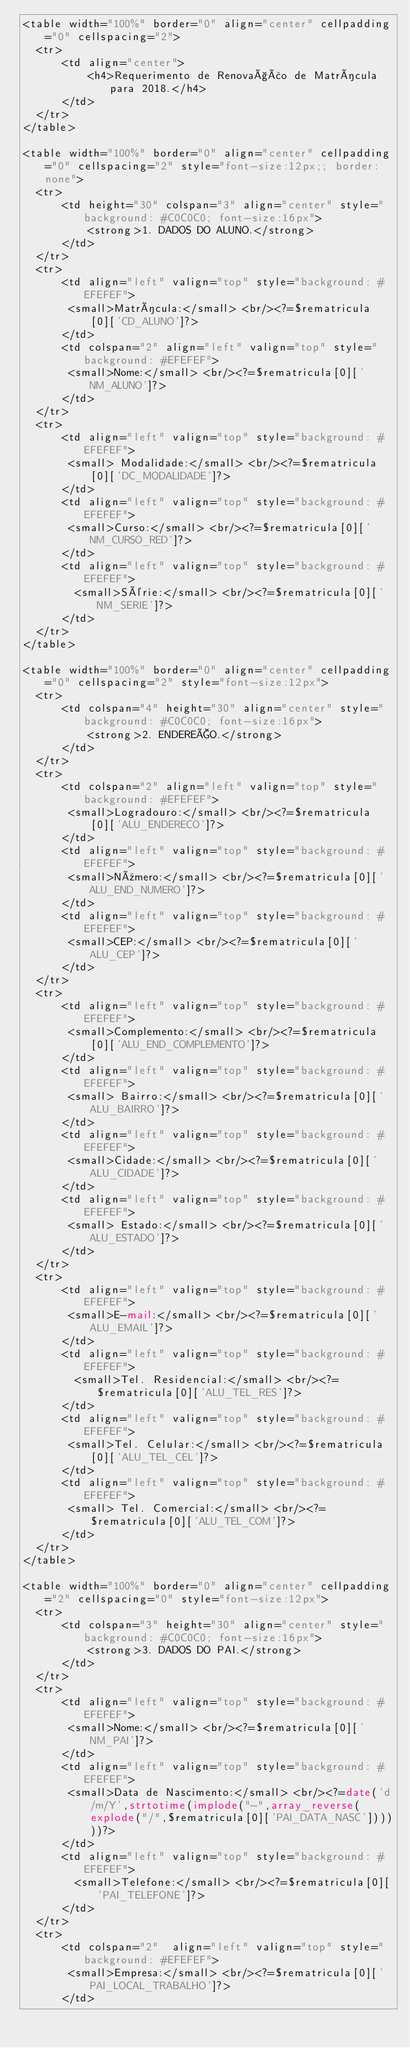<code> <loc_0><loc_0><loc_500><loc_500><_PHP_><table width="100%" border="0" align="center" cellpadding="0" cellspacing="2">
  <tr>
      <td align="center">
          <h4>Requerimento de Renovação de Matrícula para 2018.</h4>
      </td>
  </tr>
</table>

<table width="100%" border="0" align="center" cellpadding="0" cellspacing="2" style="font-size:12px;; border: none">
  <tr>
      <td height="30" colspan="3" align="center" style="background: #C0C0C0; font-size:16px">
          <strong>1. DADOS DO ALUNO.</strong>
      </td>
  </tr>
  <tr>
      <td align="left" valign="top" style="background: #EFEFEF">
       <small>Matrícula:</small> <br/><?=$rematricula[0]['CD_ALUNO']?>
      </td>  
      <td colspan="2" align="left" valign="top" style="background: #EFEFEF">
       <small>Nome:</small> <br/><?=$rematricula[0]['NM_ALUNO']?>
      </td>
  </tr>
  <tr>
      <td align="left" valign="top" style="background: #EFEFEF">
       <small> Modalidade:</small> <br/><?=$rematricula[0]['DC_MODALIDADE']?>  
      </td>
      <td align="left" valign="top" style="background: #EFEFEF">
       <small>Curso:</small> <br/><?=$rematricula[0]['NM_CURSO_RED']?>
      </td>
      <td align="left" valign="top" style="background: #EFEFEF">
        <small>Série:</small> <br/><?=$rematricula[0]['NM_SERIE']?>  
      </td>
  </tr>  
</table>

<table width="100%" border="0" align="center" cellpadding="0" cellspacing="2" style="font-size:12px">
  <tr>
      <td colspan="4" height="30" align="center" style="background: #C0C0C0; font-size:16px">
          <strong>2. ENDEREÇO.</strong>
      </td>
  </tr>
  <tr>
      <td colspan="2" align="left" valign="top" style="background: #EFEFEF">
       <small>Logradouro:</small> <br/><?=$rematricula[0]['ALU_ENDERECO']?>
      </td>
      <td align="left" valign="top" style="background: #EFEFEF">
       <small>Número:</small> <br/><?=$rematricula[0]['ALU_END_NUMERO']?>
      </td>
      <td align="left" valign="top" style="background: #EFEFEF">
       <small>CEP:</small> <br/><?=$rematricula[0]['ALU_CEP']?>
      </td>
  </tr>
  <tr>
      <td align="left" valign="top" style="background: #EFEFEF">
       <small>Complemento:</small> <br/><?=$rematricula[0]['ALU_END_COMPLEMENTO']?>
      </td>
      <td align="left" valign="top" style="background: #EFEFEF">
       <small> Bairro:</small> <br/><?=$rematricula[0]['ALU_BAIRRO']?>  
      </td>
      <td align="left" valign="top" style="background: #EFEFEF">
       <small>Cidade:</small> <br/><?=$rematricula[0]['ALU_CIDADE']?>
      </td>
      <td align="left" valign="top" style="background: #EFEFEF">
       <small> Estado:</small> <br/><?=$rematricula[0]['ALU_ESTADO']?>  
      </td>
  </tr>
  <tr>
      <td align="left" valign="top" style="background: #EFEFEF">
       <small>E-mail:</small> <br/><?=$rematricula[0]['ALU_EMAIL']?>
      </td>
      <td align="left" valign="top" style="background: #EFEFEF">
        <small>Tel. Residencial:</small> <br/><?=$rematricula[0]['ALU_TEL_RES']?>  
      </td>
      <td align="left" valign="top" style="background: #EFEFEF">
       <small>Tel. Celular:</small> <br/><?=$rematricula[0]['ALU_TEL_CEL']?>
      </td>
      <td align="left" valign="top" style="background: #EFEFEF">
       <small> Tel. Comercial:</small> <br/><?=$rematricula[0]['ALU_TEL_COM']?>  
      </td>
  </tr>
</table>

<table width="100%" border="0" align="center" cellpadding="2" cellspacing="0" style="font-size:12px">
  <tr>
      <td colspan="3" height="30" align="center" style="background: #C0C0C0; font-size:16px">
          <strong>3. DADOS DO PAI.</strong>
      </td>
  </tr>
  <tr>
      <td align="left" valign="top" style="background: #EFEFEF">
       <small>Nome:</small> <br/><?=$rematricula[0]['NM_PAI']?>
      </td>
      <td align="left" valign="top" style="background: #EFEFEF">
       <small>Data de Nascimento:</small> <br/><?=date('d/m/Y',strtotime(implode("-",array_reverse(explode("/",$rematricula[0]['PAI_DATA_NASC'])))))?>
      </td>
      <td align="left" valign="top" style="background: #EFEFEF">
        <small>Telefone:</small> <br/><?=$rematricula[0]['PAI_TELEFONE']?>  
      </td>
  </tr>
  <tr>
      <td colspan="2"  align="left" valign="top" style="background: #EFEFEF">
       <small>Empresa:</small> <br/><?=$rematricula[0]['PAI_LOCAL_TRABALHO']?>
      </td></code> 